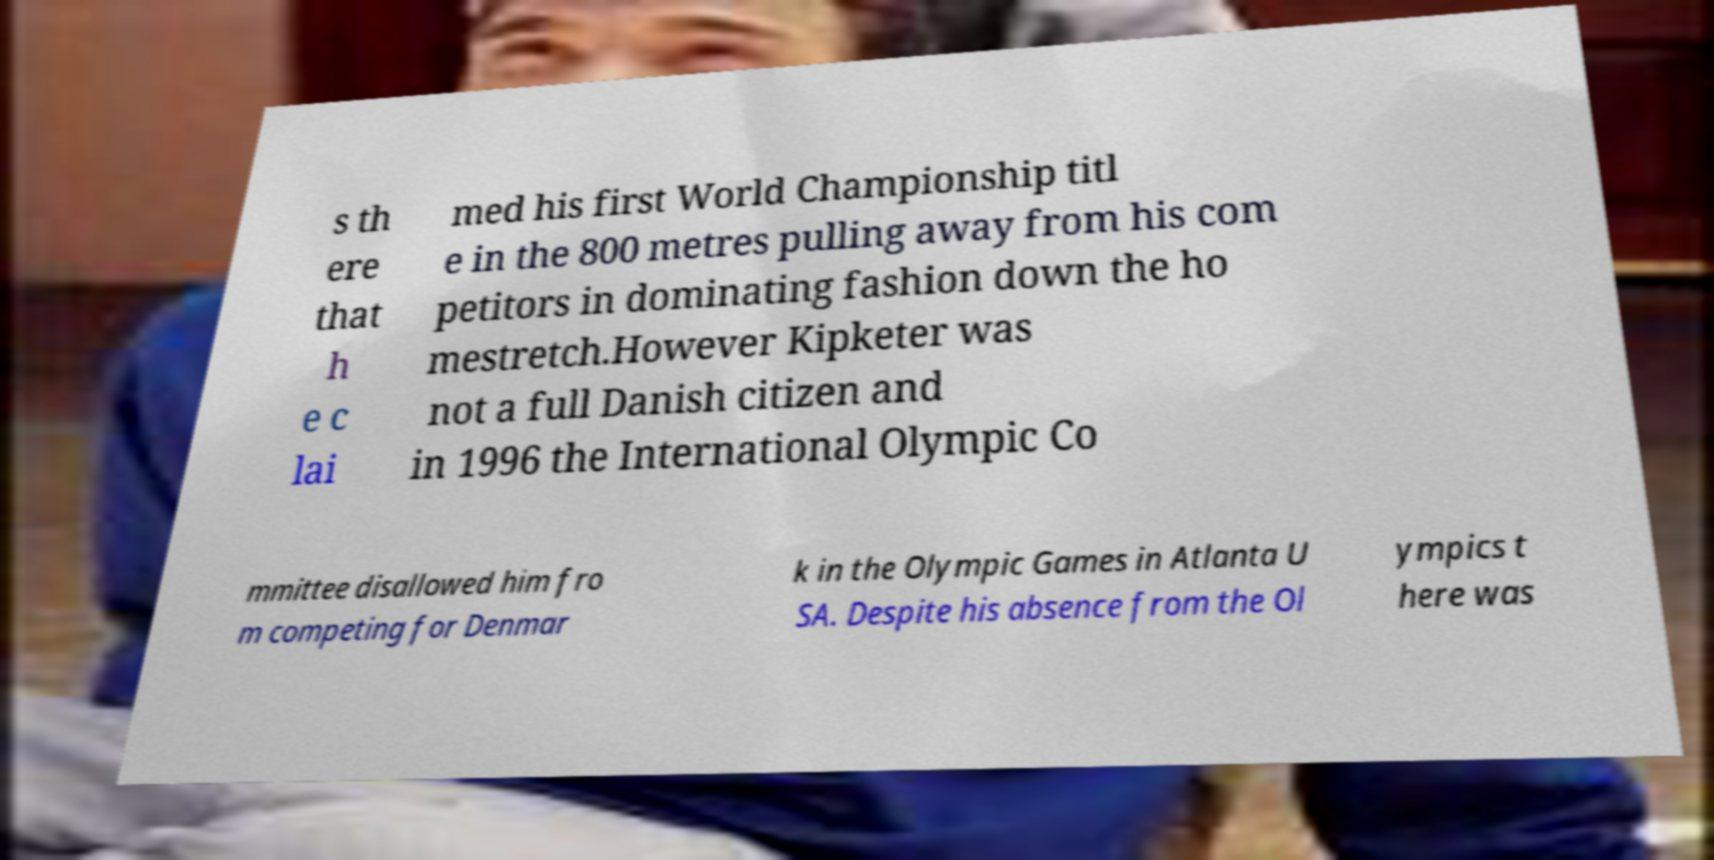For documentation purposes, I need the text within this image transcribed. Could you provide that? s th ere that h e c lai med his first World Championship titl e in the 800 metres pulling away from his com petitors in dominating fashion down the ho mestretch.However Kipketer was not a full Danish citizen and in 1996 the International Olympic Co mmittee disallowed him fro m competing for Denmar k in the Olympic Games in Atlanta U SA. Despite his absence from the Ol ympics t here was 